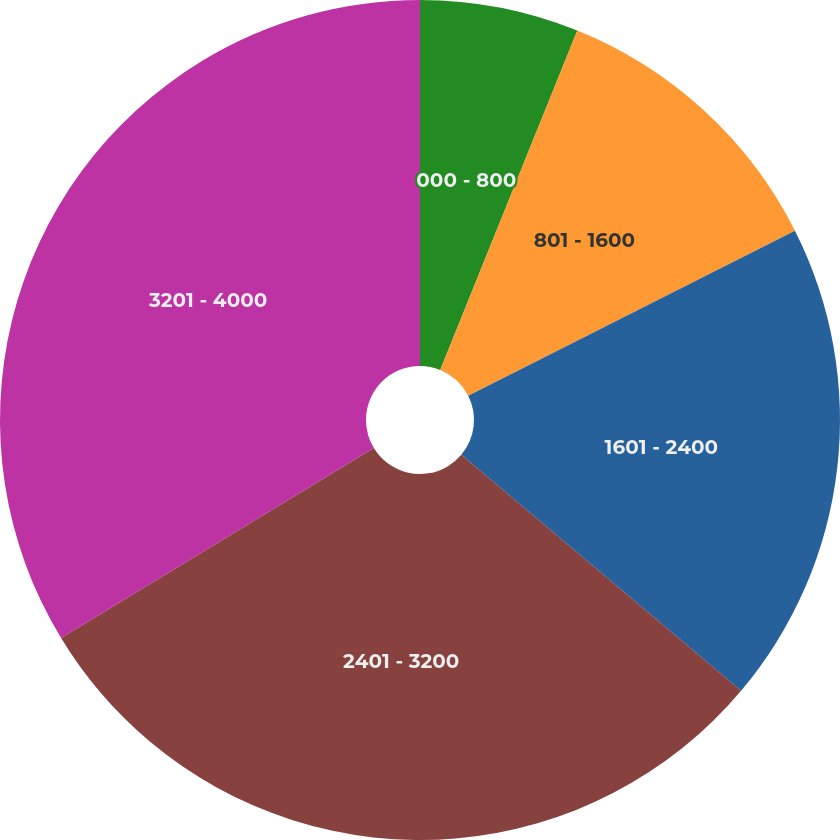Convert chart. <chart><loc_0><loc_0><loc_500><loc_500><pie_chart><fcel>000 - 800<fcel>801 - 1600<fcel>1601 - 2400<fcel>2401 - 3200<fcel>3201 - 4000<nl><fcel>6.11%<fcel>11.45%<fcel>18.59%<fcel>30.16%<fcel>33.69%<nl></chart> 